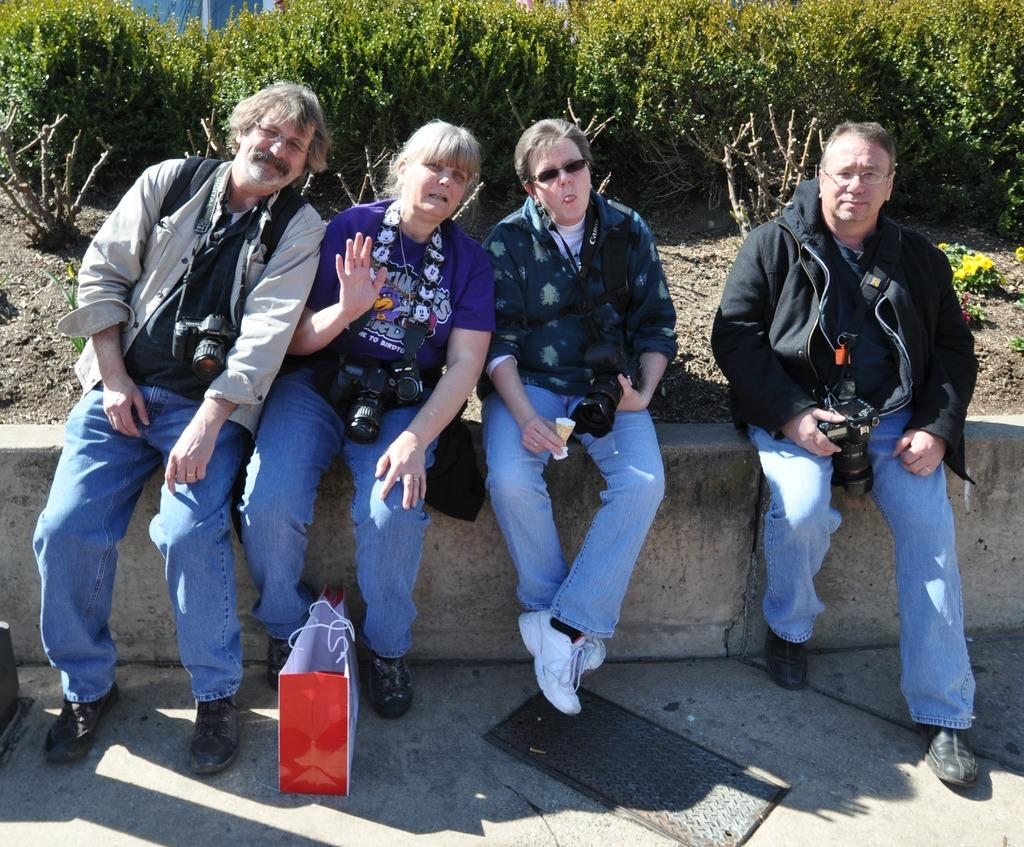What are the people in the image doing? The people in the image are sitting on a wall. What is on the ground near the people? There is a bag on the ground in the image. What type of vegetation can be seen in the image? There are green plants visible in the image. What type of clouds can be seen in the image? There are no clouds visible in the image; it appears to be a clear day. How many legs are visible in the image? The provided facts do not mention any legs, so it is impossible to determine the number of legs visible in the image. 